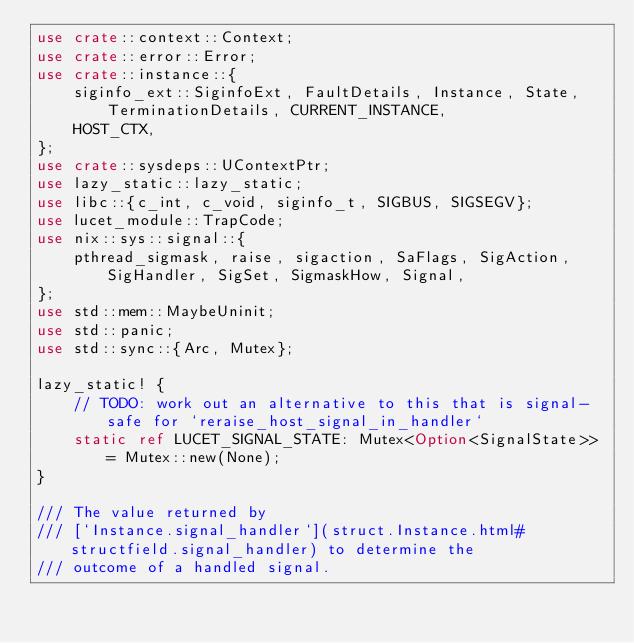Convert code to text. <code><loc_0><loc_0><loc_500><loc_500><_Rust_>use crate::context::Context;
use crate::error::Error;
use crate::instance::{
    siginfo_ext::SiginfoExt, FaultDetails, Instance, State, TerminationDetails, CURRENT_INSTANCE,
    HOST_CTX,
};
use crate::sysdeps::UContextPtr;
use lazy_static::lazy_static;
use libc::{c_int, c_void, siginfo_t, SIGBUS, SIGSEGV};
use lucet_module::TrapCode;
use nix::sys::signal::{
    pthread_sigmask, raise, sigaction, SaFlags, SigAction, SigHandler, SigSet, SigmaskHow, Signal,
};
use std::mem::MaybeUninit;
use std::panic;
use std::sync::{Arc, Mutex};

lazy_static! {
    // TODO: work out an alternative to this that is signal-safe for `reraise_host_signal_in_handler`
    static ref LUCET_SIGNAL_STATE: Mutex<Option<SignalState>> = Mutex::new(None);
}

/// The value returned by
/// [`Instance.signal_handler`](struct.Instance.html#structfield.signal_handler) to determine the
/// outcome of a handled signal.</code> 